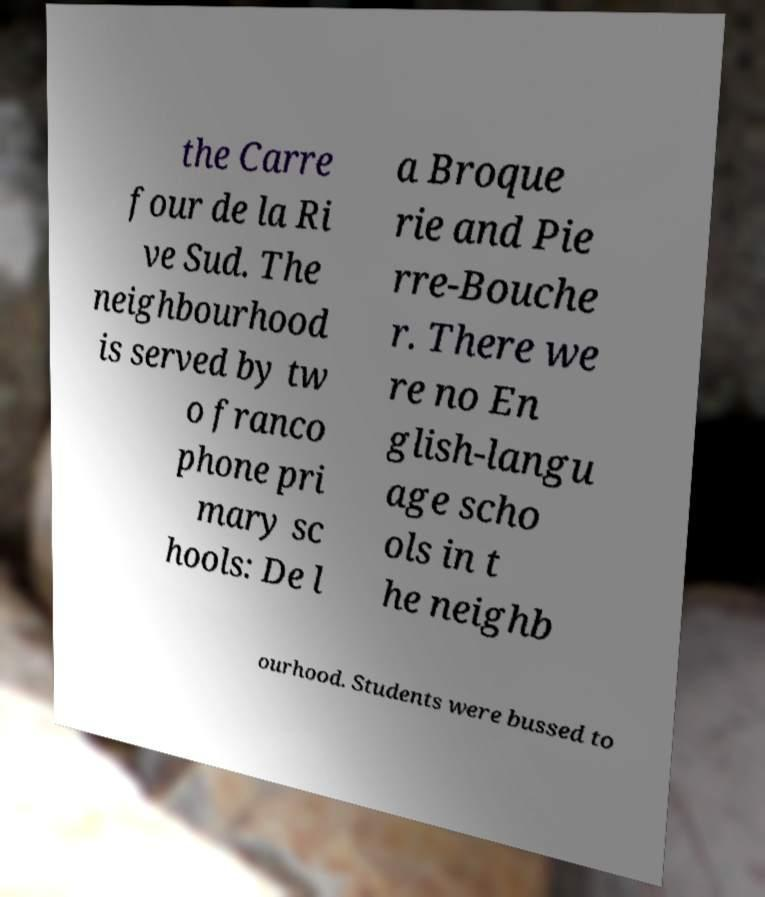Please read and relay the text visible in this image. What does it say? the Carre four de la Ri ve Sud. The neighbourhood is served by tw o franco phone pri mary sc hools: De l a Broque rie and Pie rre-Bouche r. There we re no En glish-langu age scho ols in t he neighb ourhood. Students were bussed to 